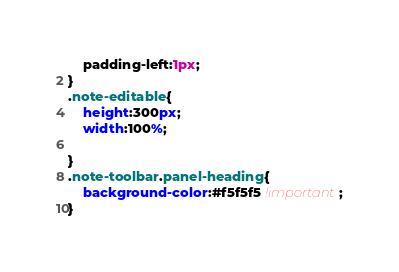Convert code to text. <code><loc_0><loc_0><loc_500><loc_500><_CSS_>    padding-left:1px;
}
.note-editable{
    height:300px;
    width:100%;

}
.note-toolbar.panel-heading{
    background-color:#f5f5f5 !important;
}
</code> 